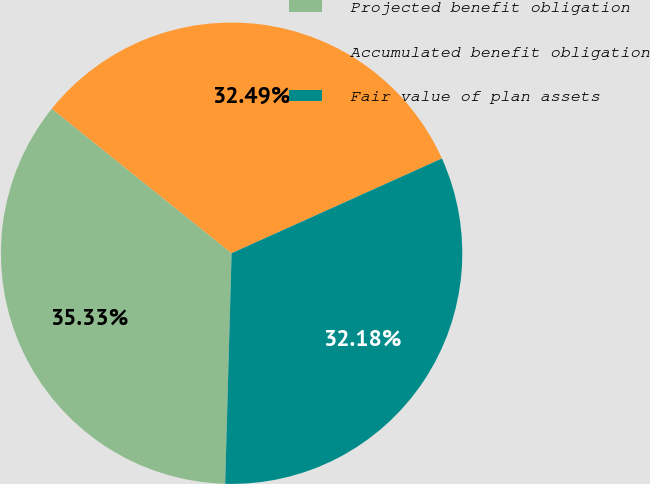<chart> <loc_0><loc_0><loc_500><loc_500><pie_chart><fcel>Projected benefit obligation<fcel>Accumulated benefit obligation<fcel>Fair value of plan assets<nl><fcel>35.33%<fcel>32.49%<fcel>32.18%<nl></chart> 